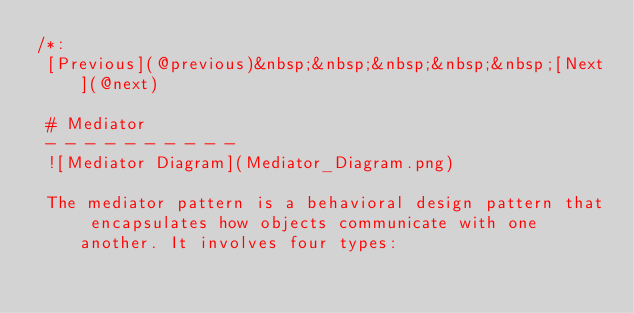Convert code to text. <code><loc_0><loc_0><loc_500><loc_500><_Swift_>/*:
 [Previous](@previous)&nbsp;&nbsp;&nbsp;&nbsp;&nbsp;[Next](@next)
 
 # Mediator
 - - - - - - - - - -
 ![Mediator Diagram](Mediator_Diagram.png)
 
 The mediator pattern is a behavioral design pattern that encapsulates how objects communicate with one another. It involves four types:</code> 